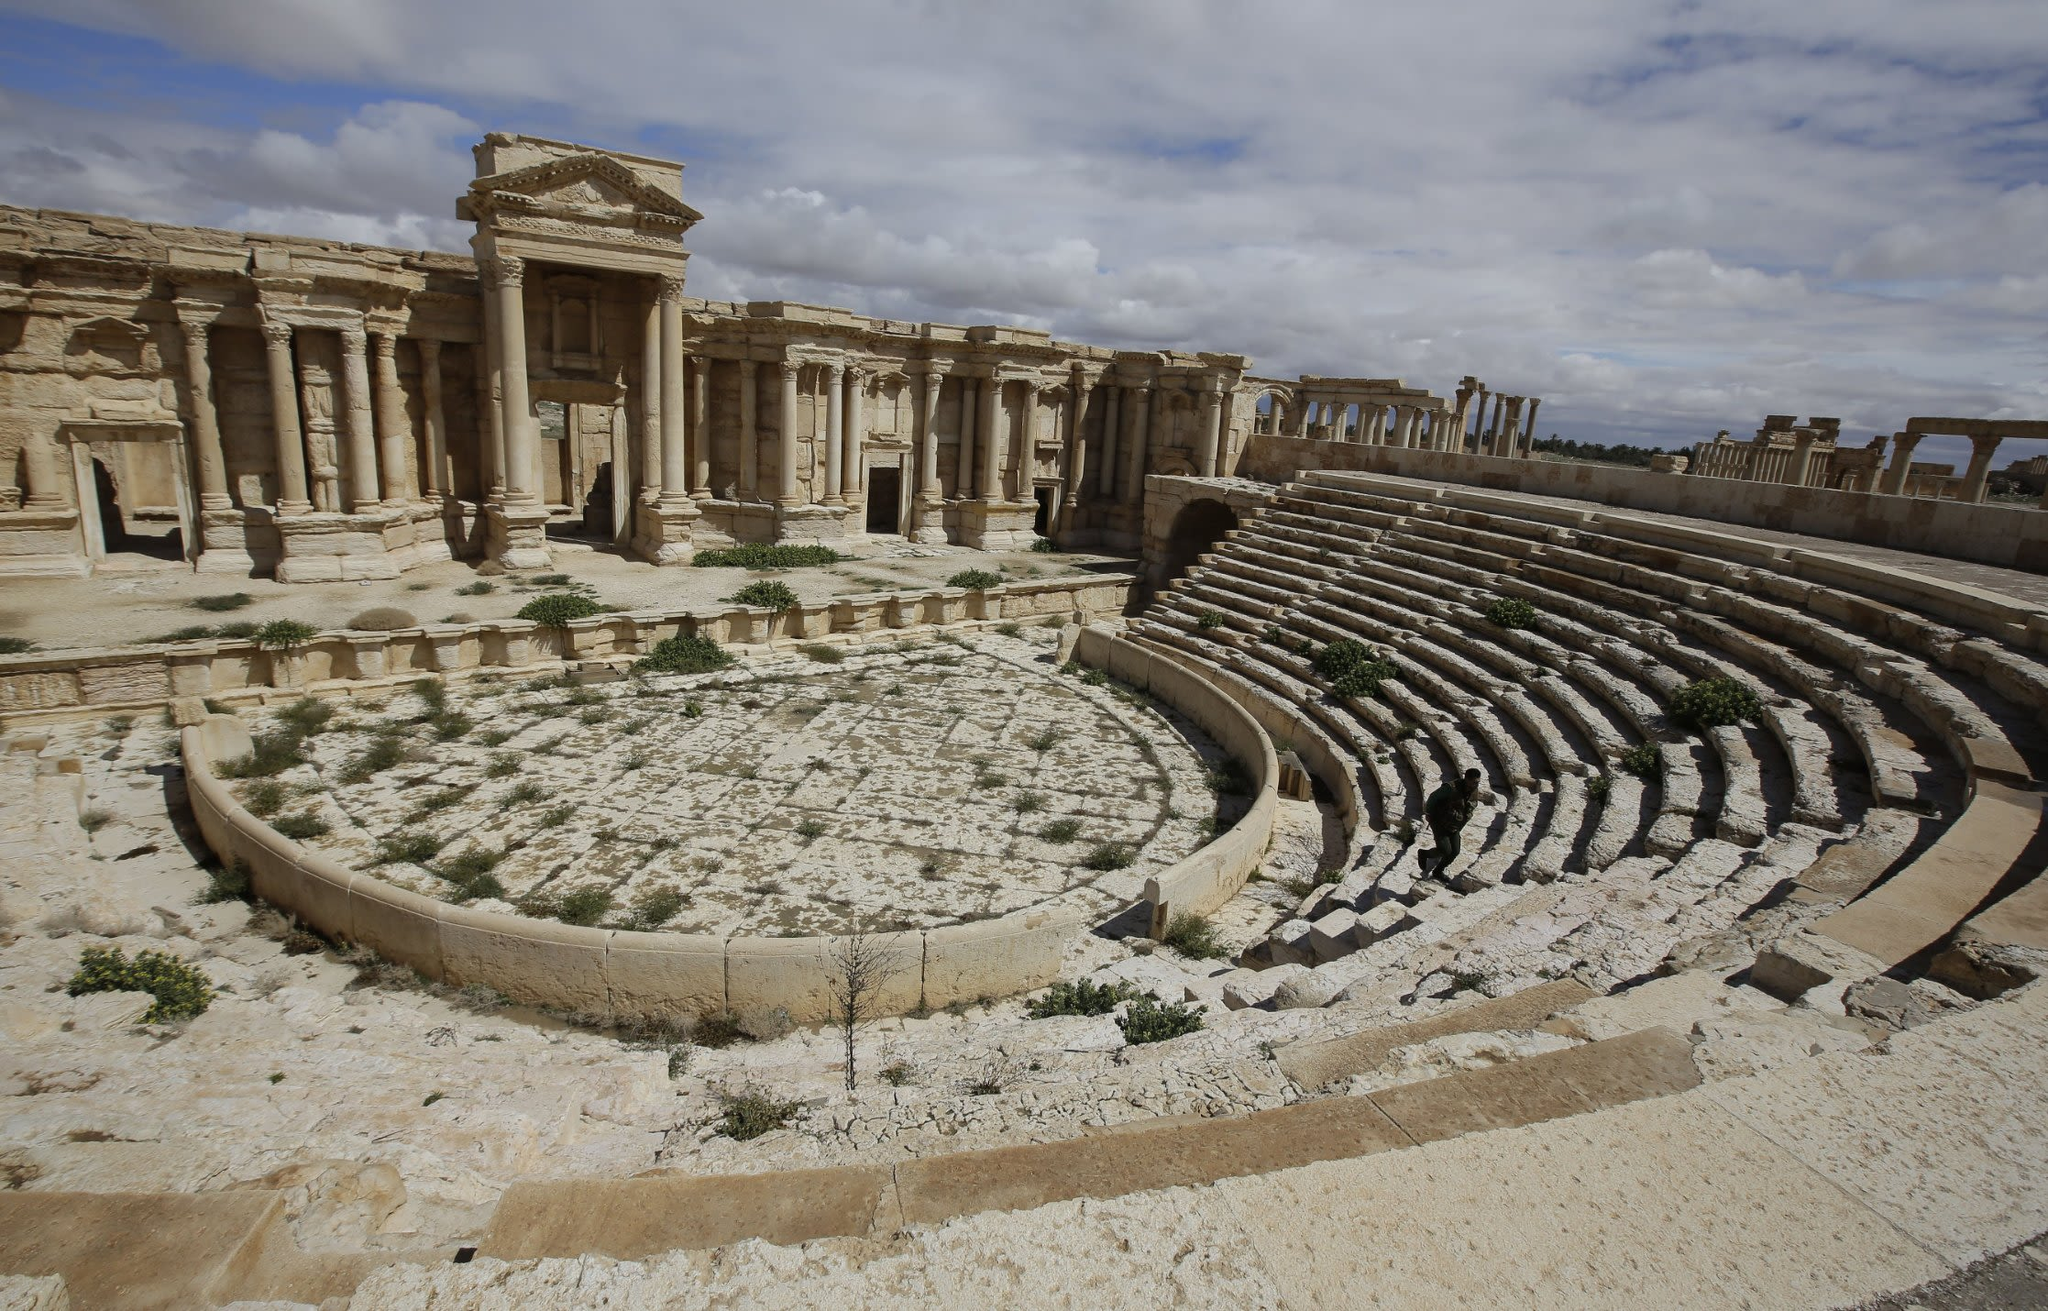If you were to plan a film, how would you use this location? If planning a film using the ancient theater of Palmyra as a location, the setting would undoubtedly provide a dramatic and immersive backdrop. The film could be a historical epic, capturing the grandeur and complexities of ancient civilizations. Imagine a plot centered around the lives of those who lived in Palmyra, including the traders, performers, and citizens who frequented the theater. Alternatively, it could be a modern-day archaeological adventure, where a daring explorer unearths hidden relics and untangles ancient mysteries buried within the ruins. The contrast of the ruins against the modern world would highlight themes of time, legacy, and the search for meaning in history. The theater itself, with its haunting beauty and historical resonance, would serve as both a character in the story and a visual spectacle, enriching the narrative with its timeless allure. 